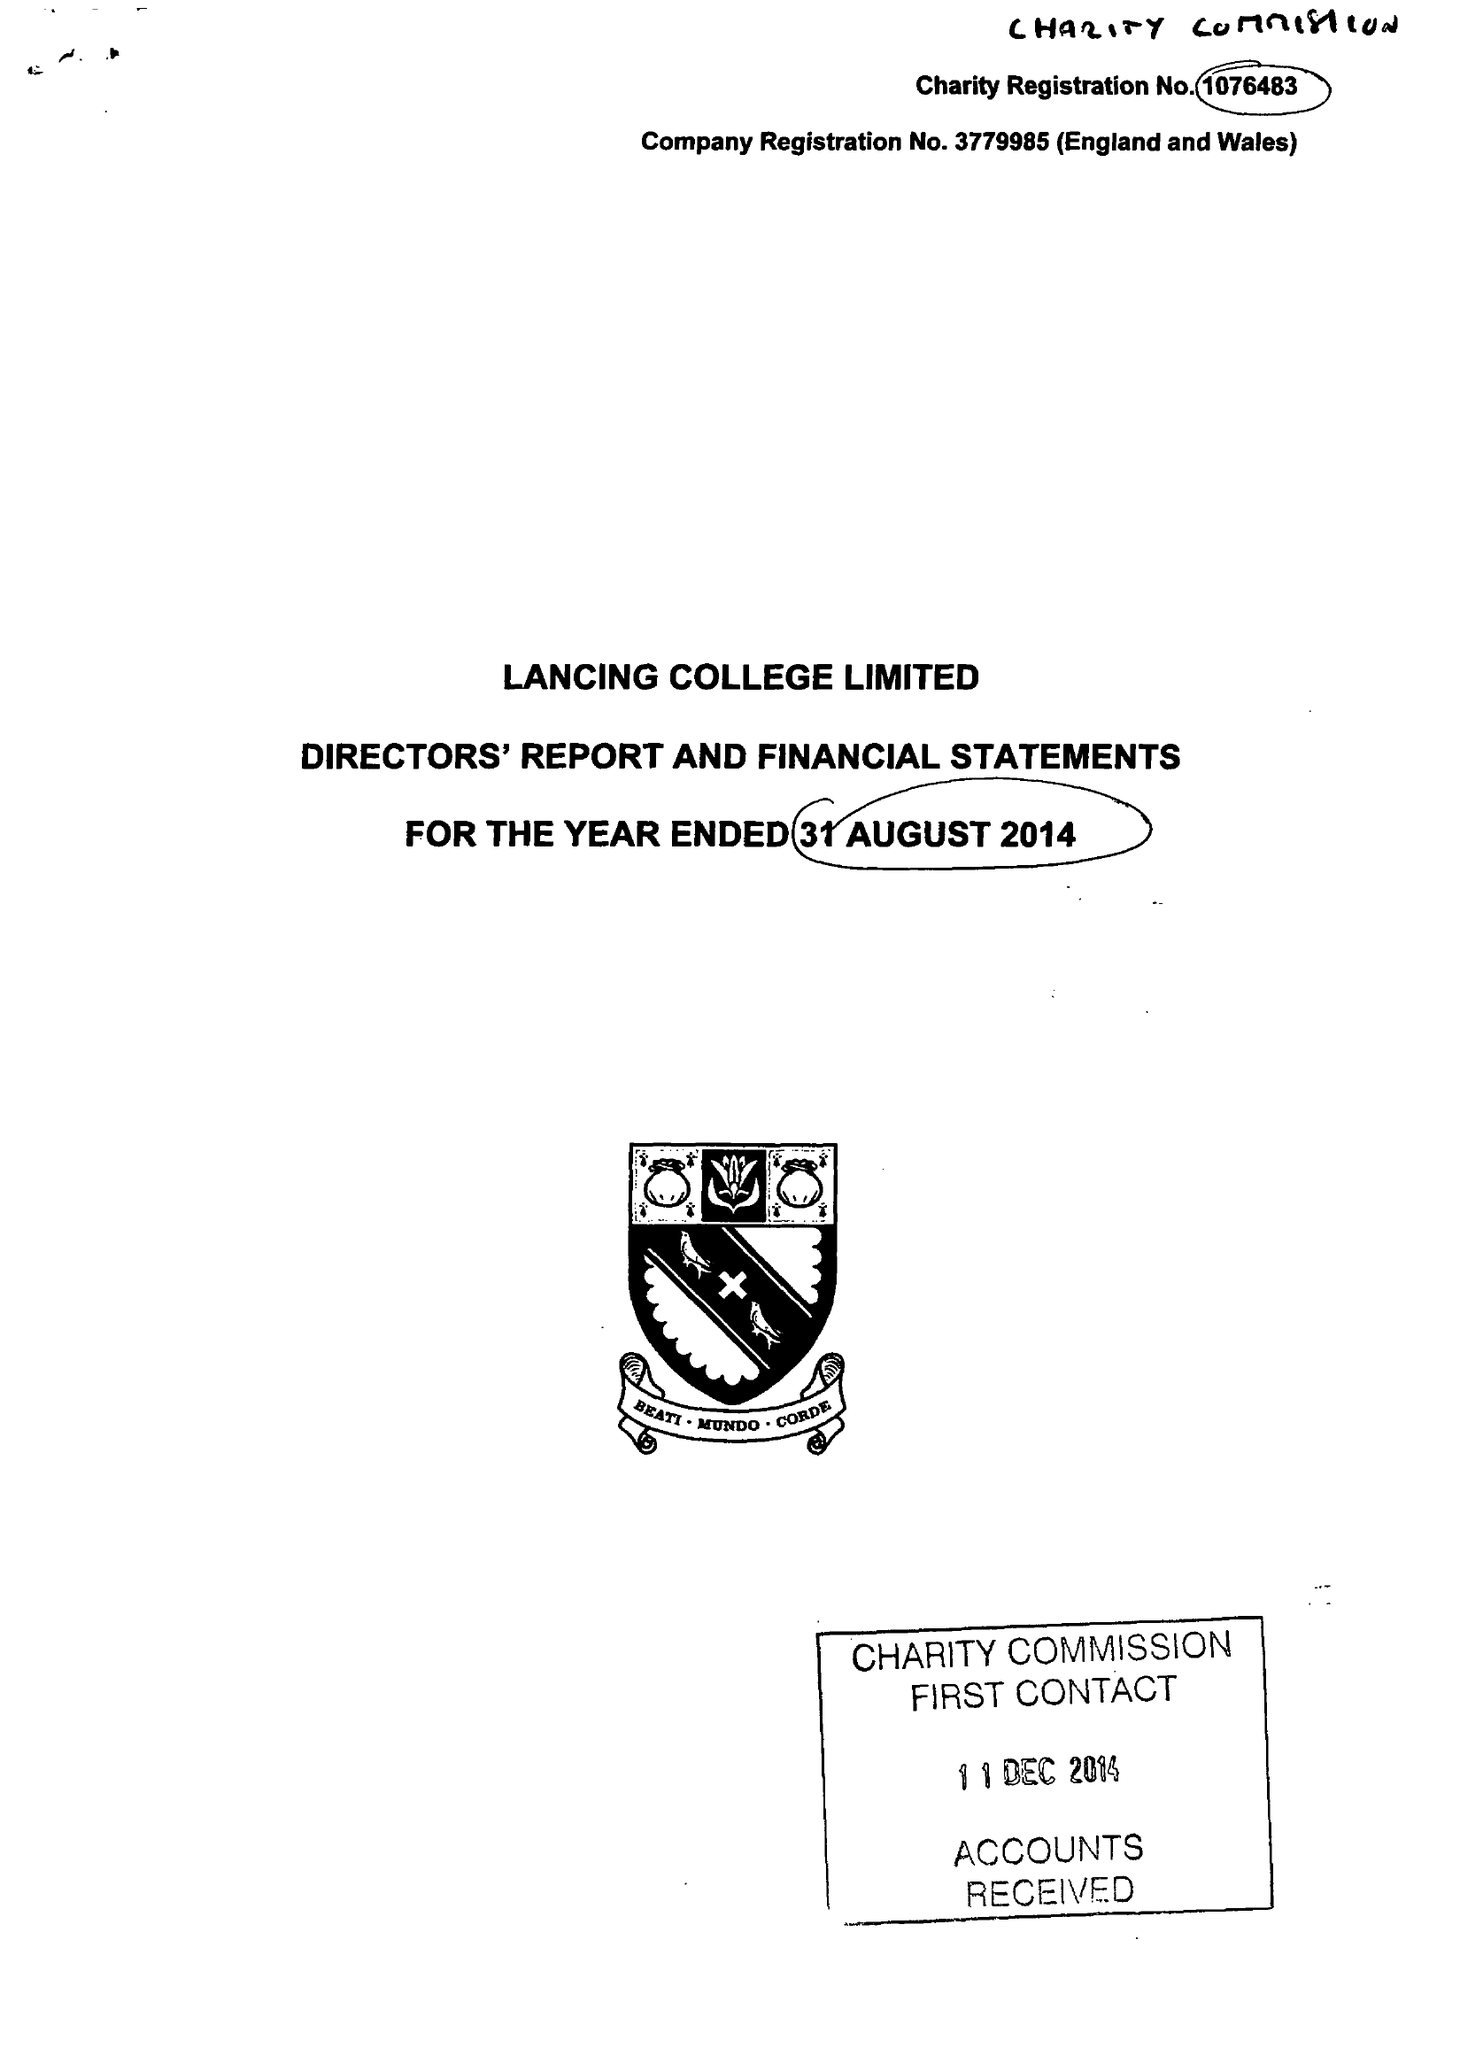What is the value for the charity_number?
Answer the question using a single word or phrase. 1076483 